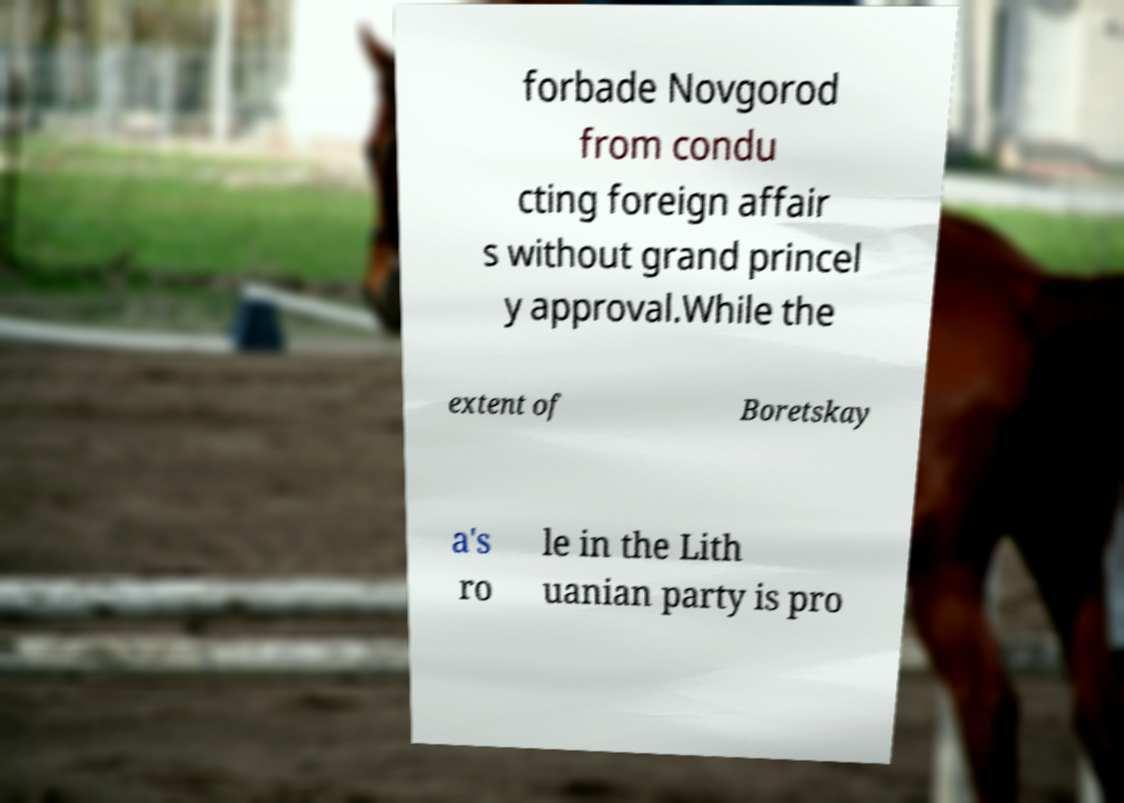Can you read and provide the text displayed in the image?This photo seems to have some interesting text. Can you extract and type it out for me? forbade Novgorod from condu cting foreign affair s without grand princel y approval.While the extent of Boretskay a's ro le in the Lith uanian party is pro 